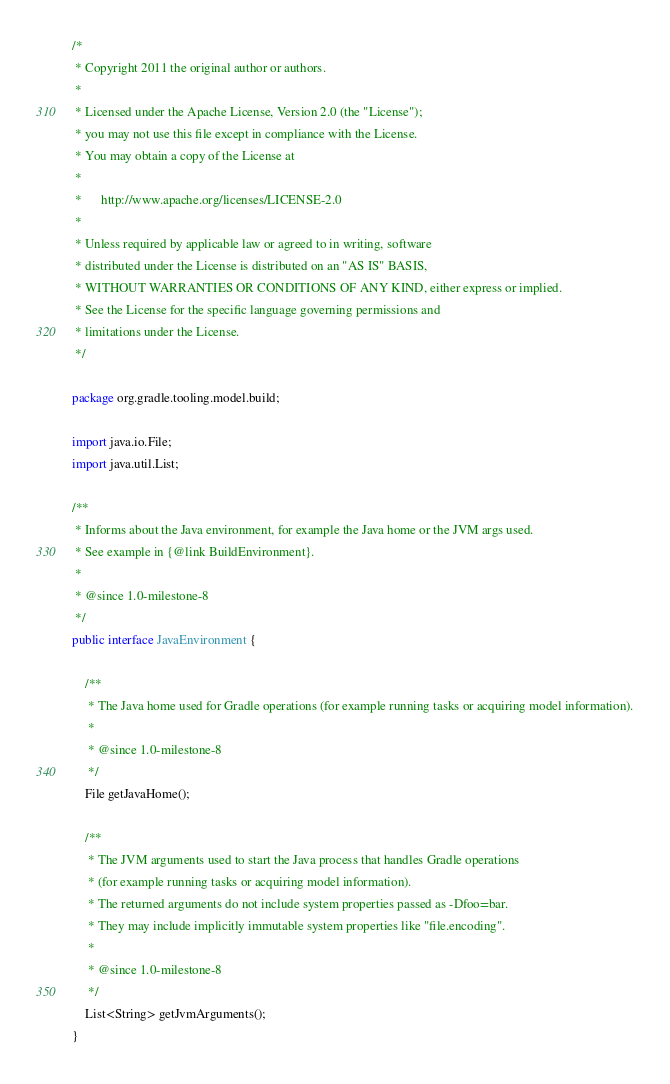<code> <loc_0><loc_0><loc_500><loc_500><_Java_>/*
 * Copyright 2011 the original author or authors.
 *
 * Licensed under the Apache License, Version 2.0 (the "License");
 * you may not use this file except in compliance with the License.
 * You may obtain a copy of the License at
 *
 *      http://www.apache.org/licenses/LICENSE-2.0
 *
 * Unless required by applicable law or agreed to in writing, software
 * distributed under the License is distributed on an "AS IS" BASIS,
 * WITHOUT WARRANTIES OR CONDITIONS OF ANY KIND, either express or implied.
 * See the License for the specific language governing permissions and
 * limitations under the License.
 */

package org.gradle.tooling.model.build;

import java.io.File;
import java.util.List;

/**
 * Informs about the Java environment, for example the Java home or the JVM args used.
 * See example in {@link BuildEnvironment}.
 *
 * @since 1.0-milestone-8
 */
public interface JavaEnvironment {

    /**
     * The Java home used for Gradle operations (for example running tasks or acquiring model information).
     *
     * @since 1.0-milestone-8
     */
    File getJavaHome();

    /**
     * The JVM arguments used to start the Java process that handles Gradle operations
     * (for example running tasks or acquiring model information).
     * The returned arguments do not include system properties passed as -Dfoo=bar.
     * They may include implicitly immutable system properties like "file.encoding".
     *
     * @since 1.0-milestone-8
     */
    List<String> getJvmArguments();
}
</code> 